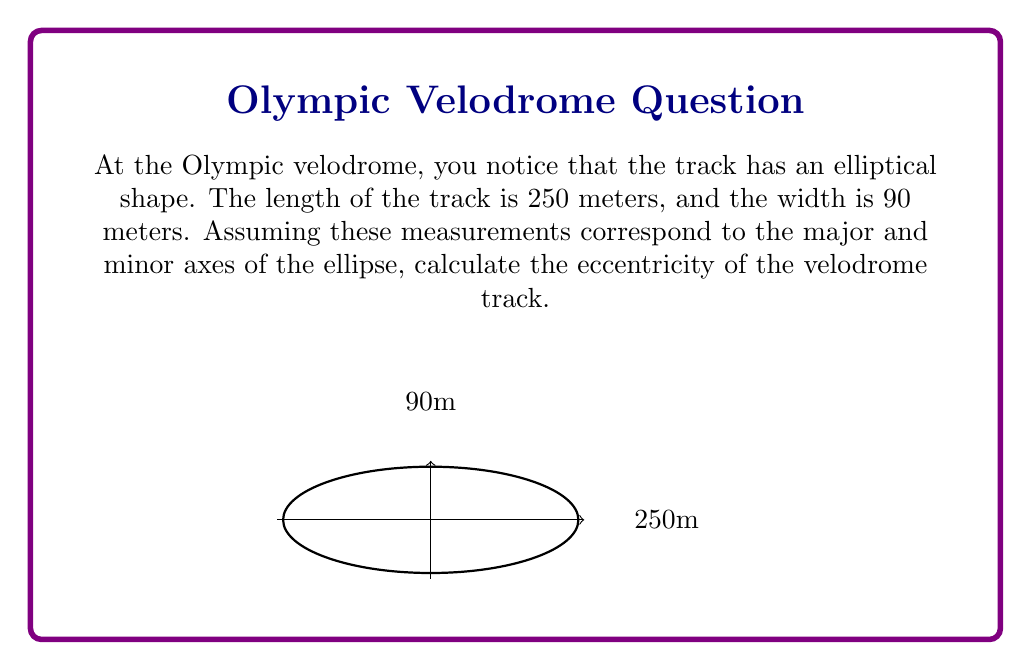Solve this math problem. Let's approach this step-by-step:

1) In an ellipse, eccentricity (e) is given by the formula:

   $$e = \sqrt{1 - \frac{b^2}{a^2}}$$

   where $a$ is the semi-major axis and $b$ is the semi-minor axis.

2) From the given information:
   - Length (2a) = 250 m
   - Width (2b) = 90 m

3) Calculate $a$ and $b$:
   $$a = \frac{250}{2} = 125 \text{ m}$$
   $$b = \frac{90}{2} = 45 \text{ m}$$

4) Now, substitute these values into the eccentricity formula:

   $$e = \sqrt{1 - \frac{b^2}{a^2}}$$
   $$e = \sqrt{1 - \frac{45^2}{125^2}}$$

5) Simplify:
   $$e = \sqrt{1 - \frac{2025}{15625}}$$
   $$e = \sqrt{1 - 0.1296}$$
   $$e = \sqrt{0.8704}$$

6) Calculate the final result:
   $$e \approx 0.9329$$

Thus, the eccentricity of the velodrome track is approximately 0.9329.
Answer: $0.9329$ 